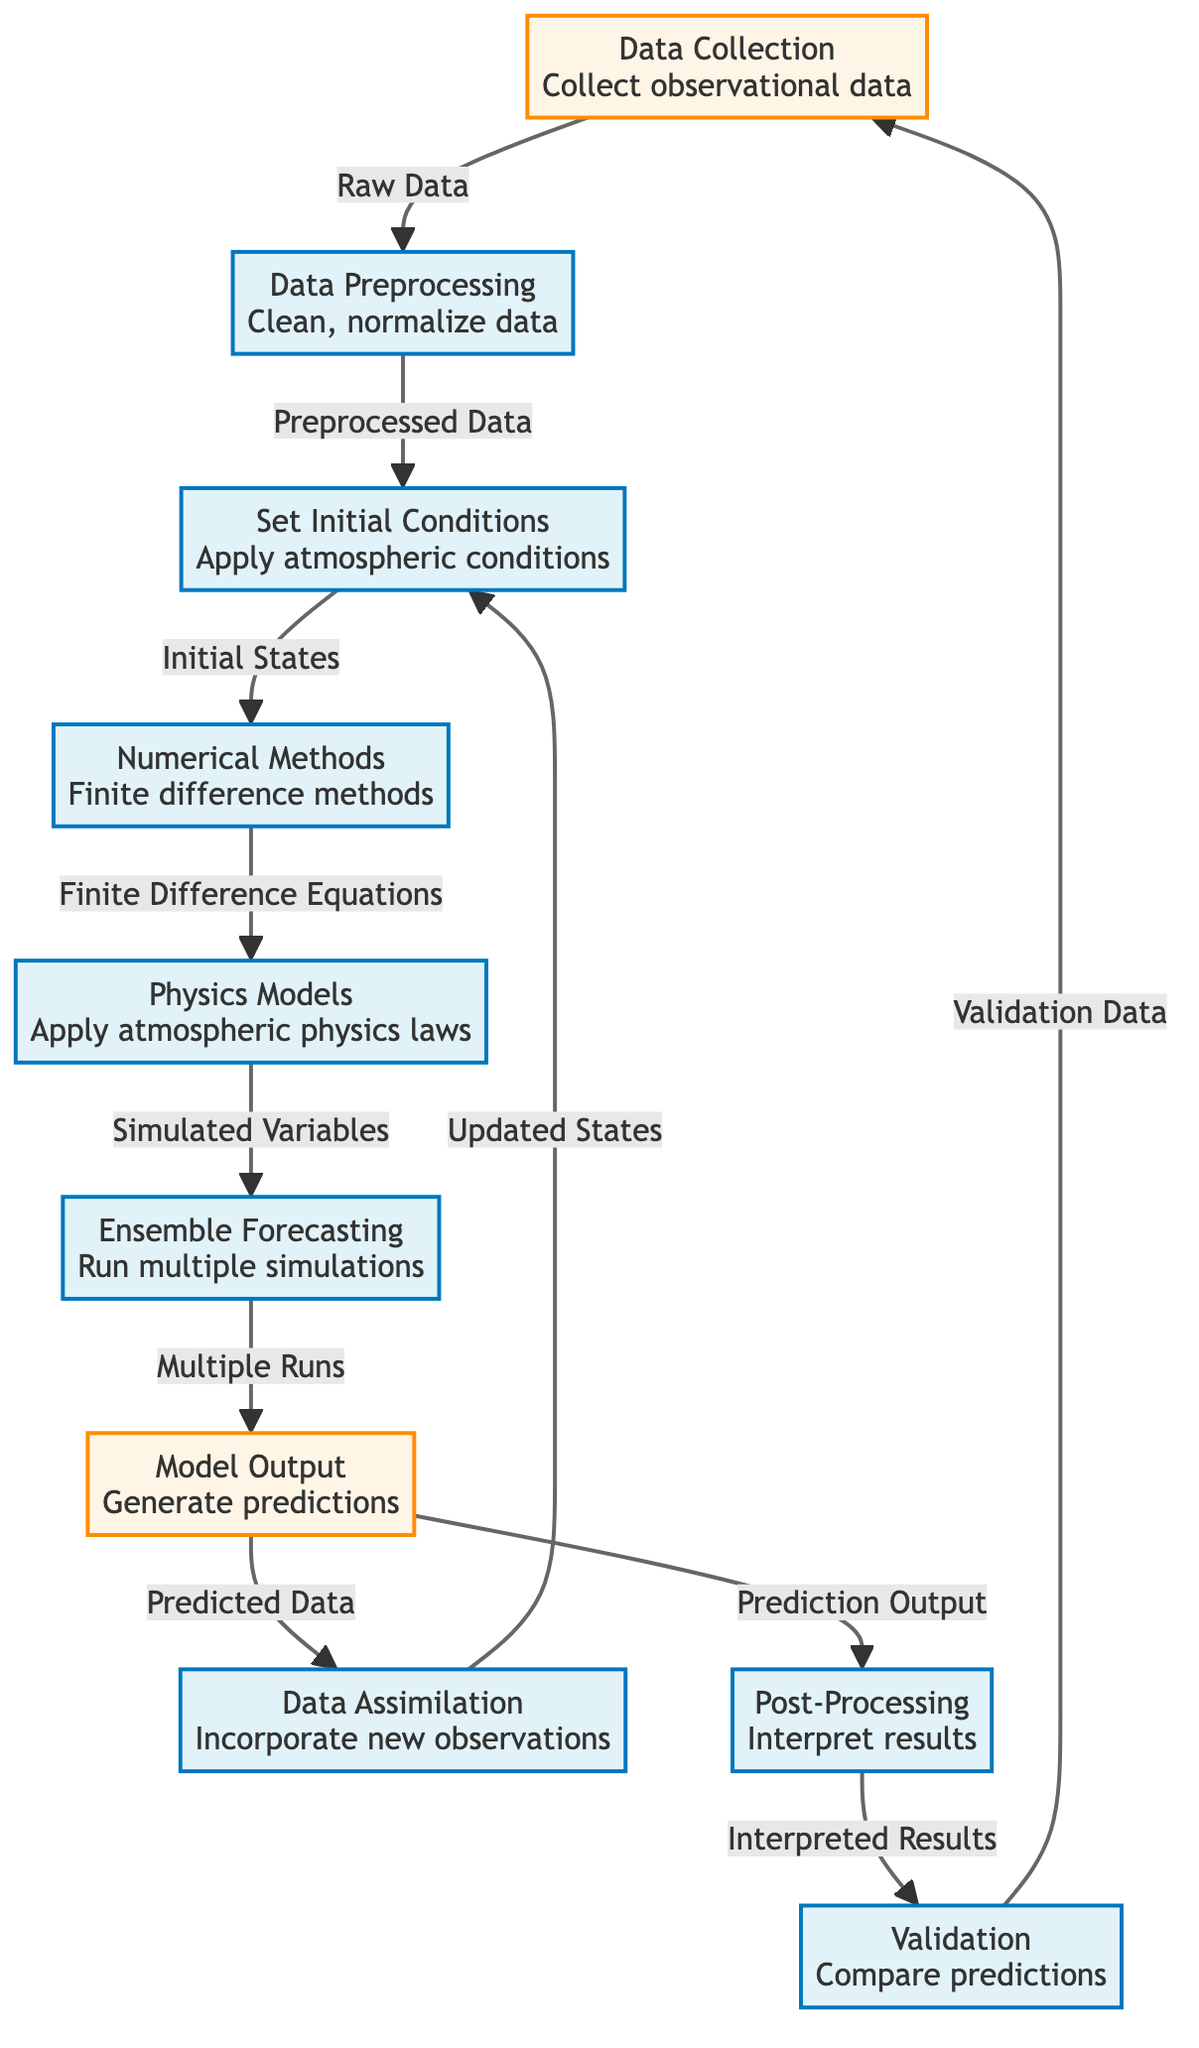What is the first step in the flowchart? The flowchart starts with "Data Collection," which is the first node in the sequence, indicating it's the entry point for the process.
Answer: Data Collection How many processes are there in the diagram? By counting the nodes designated as processes, there are a total of six distinct process nodes listed in the flowchart.
Answer: Six What type of data is collected after model output? According to the flowchart, after the "Model Output" node, the output generated is referred to as "Predicted Data," clearly indicating what type of data is collected.
Answer: Predicted Data Which node follows the "Ensemble Forecasting" step? The node that follows "Ensemble Forecasting" is "Model Output," indicating that after multiple simulations, the predictions are generated next.
Answer: Model Output What is the last step before validation? Before reaching the "Validation" stage, the flowchart indicates a preceding step of "Post-Processing," which suggests that results are interpreted prior to the validation process.
Answer: Post-Processing Which step is responsible for incorporating new observations? The diagram specifies that the "Data Assimilation" step is where new observations are incorporated into the model process, reflecting an important component of the forecasting workflow.
Answer: Data Assimilation How does "Post-Processing" relate to "Model Output"? From the flowchart, "Post-Processing" takes "Prediction Output" from "Model Output," indicating a direct relationship where output predictions are interpreted in this step.
Answer: Prediction Output What is the purpose of "Data Preprocessing"? "Data Preprocessing" is meant to "Clean, normalize data," as described in the flowchart, which is critical for ensuring that the data is ready for further processing.
Answer: Clean, normalize data 